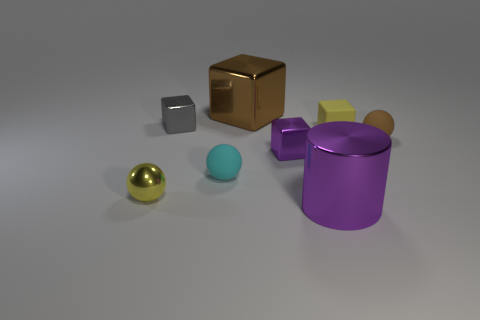Can you describe the colors and the number of objects present? Certainly, there are six objects with distinct colors in the image: gold, gray, yellow, purple, teal, and a metallic shade that seems like a blend of gold and silver. 